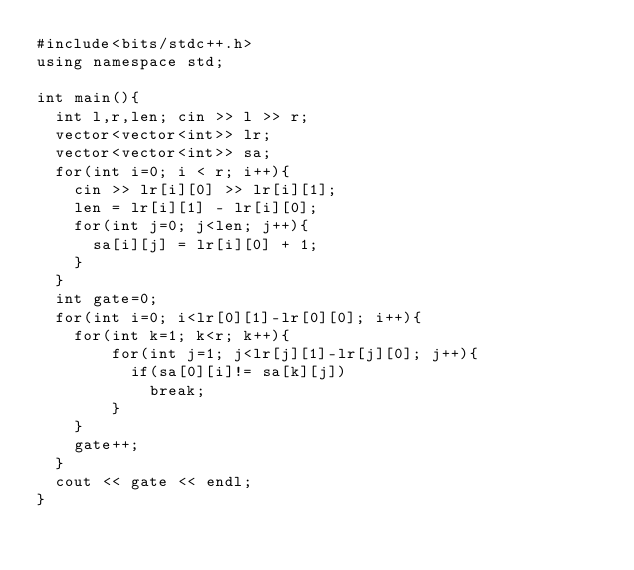Convert code to text. <code><loc_0><loc_0><loc_500><loc_500><_C++_>#include<bits/stdc++.h>
using namespace std;

int main(){
  int l,r,len; cin >> l >> r;
  vector<vector<int>> lr;
  vector<vector<int>> sa;
  for(int i=0; i < r; i++){
    cin >> lr[i][0] >> lr[i][1];
    len = lr[i][1] - lr[i][0];
    for(int j=0; j<len; j++){
      sa[i][j] = lr[i][0] + 1;
    }
  }
  int gate=0;
  for(int i=0; i<lr[0][1]-lr[0][0]; i++){
    for(int k=1; k<r; k++){
   		for(int j=1; j<lr[j][1]-lr[j][0]; j++){
          if(sa[0][i]!= sa[k][j])
            break;
        }
    }
    gate++;
  }
  cout << gate << endl;
}
            
      
    
  
  </code> 